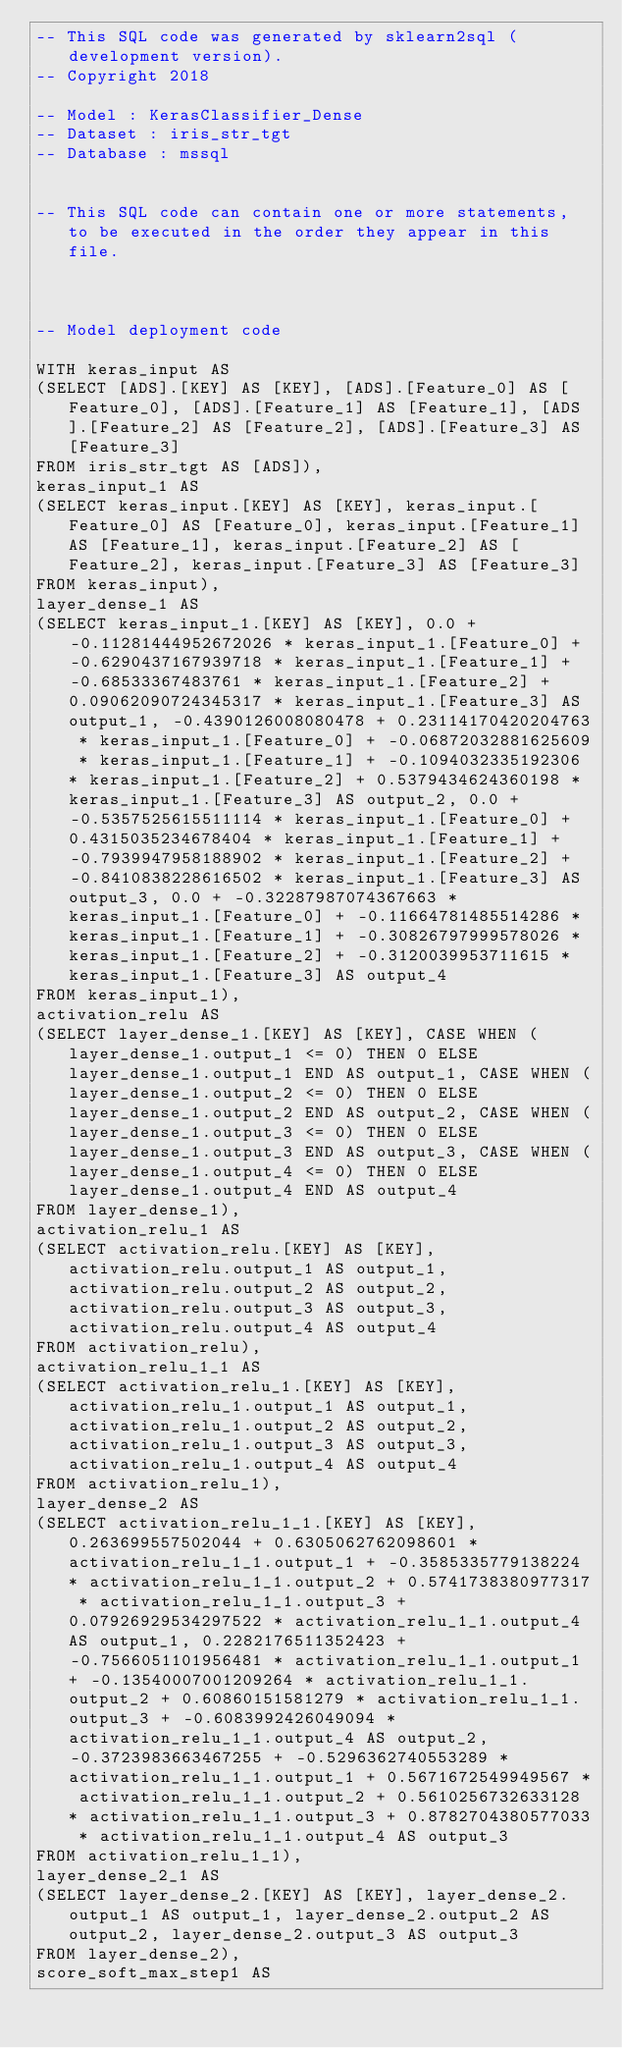<code> <loc_0><loc_0><loc_500><loc_500><_SQL_>-- This SQL code was generated by sklearn2sql (development version).
-- Copyright 2018

-- Model : KerasClassifier_Dense
-- Dataset : iris_str_tgt
-- Database : mssql


-- This SQL code can contain one or more statements, to be executed in the order they appear in this file.



-- Model deployment code

WITH keras_input AS 
(SELECT [ADS].[KEY] AS [KEY], [ADS].[Feature_0] AS [Feature_0], [ADS].[Feature_1] AS [Feature_1], [ADS].[Feature_2] AS [Feature_2], [ADS].[Feature_3] AS [Feature_3] 
FROM iris_str_tgt AS [ADS]), 
keras_input_1 AS 
(SELECT keras_input.[KEY] AS [KEY], keras_input.[Feature_0] AS [Feature_0], keras_input.[Feature_1] AS [Feature_1], keras_input.[Feature_2] AS [Feature_2], keras_input.[Feature_3] AS [Feature_3] 
FROM keras_input), 
layer_dense_1 AS 
(SELECT keras_input_1.[KEY] AS [KEY], 0.0 + -0.11281444952672026 * keras_input_1.[Feature_0] + -0.6290437167939718 * keras_input_1.[Feature_1] + -0.68533367483761 * keras_input_1.[Feature_2] + 0.09062090724345317 * keras_input_1.[Feature_3] AS output_1, -0.4390126008080478 + 0.23114170420204763 * keras_input_1.[Feature_0] + -0.06872032881625609 * keras_input_1.[Feature_1] + -0.1094032335192306 * keras_input_1.[Feature_2] + 0.5379434624360198 * keras_input_1.[Feature_3] AS output_2, 0.0 + -0.5357525615511114 * keras_input_1.[Feature_0] + 0.4315035234678404 * keras_input_1.[Feature_1] + -0.7939947958188902 * keras_input_1.[Feature_2] + -0.8410838228616502 * keras_input_1.[Feature_3] AS output_3, 0.0 + -0.32287987074367663 * keras_input_1.[Feature_0] + -0.11664781485514286 * keras_input_1.[Feature_1] + -0.30826797999578026 * keras_input_1.[Feature_2] + -0.3120039953711615 * keras_input_1.[Feature_3] AS output_4 
FROM keras_input_1), 
activation_relu AS 
(SELECT layer_dense_1.[KEY] AS [KEY], CASE WHEN (layer_dense_1.output_1 <= 0) THEN 0 ELSE layer_dense_1.output_1 END AS output_1, CASE WHEN (layer_dense_1.output_2 <= 0) THEN 0 ELSE layer_dense_1.output_2 END AS output_2, CASE WHEN (layer_dense_1.output_3 <= 0) THEN 0 ELSE layer_dense_1.output_3 END AS output_3, CASE WHEN (layer_dense_1.output_4 <= 0) THEN 0 ELSE layer_dense_1.output_4 END AS output_4 
FROM layer_dense_1), 
activation_relu_1 AS 
(SELECT activation_relu.[KEY] AS [KEY], activation_relu.output_1 AS output_1, activation_relu.output_2 AS output_2, activation_relu.output_3 AS output_3, activation_relu.output_4 AS output_4 
FROM activation_relu), 
activation_relu_1_1 AS 
(SELECT activation_relu_1.[KEY] AS [KEY], activation_relu_1.output_1 AS output_1, activation_relu_1.output_2 AS output_2, activation_relu_1.output_3 AS output_3, activation_relu_1.output_4 AS output_4 
FROM activation_relu_1), 
layer_dense_2 AS 
(SELECT activation_relu_1_1.[KEY] AS [KEY], 0.263699557502044 + 0.6305062762098601 * activation_relu_1_1.output_1 + -0.3585335779138224 * activation_relu_1_1.output_2 + 0.5741738380977317 * activation_relu_1_1.output_3 + 0.07926929534297522 * activation_relu_1_1.output_4 AS output_1, 0.2282176511352423 + -0.7566051101956481 * activation_relu_1_1.output_1 + -0.13540007001209264 * activation_relu_1_1.output_2 + 0.60860151581279 * activation_relu_1_1.output_3 + -0.6083992426049094 * activation_relu_1_1.output_4 AS output_2, -0.3723983663467255 + -0.5296362740553289 * activation_relu_1_1.output_1 + 0.5671672549949567 * activation_relu_1_1.output_2 + 0.5610256732633128 * activation_relu_1_1.output_3 + 0.8782704380577033 * activation_relu_1_1.output_4 AS output_3 
FROM activation_relu_1_1), 
layer_dense_2_1 AS 
(SELECT layer_dense_2.[KEY] AS [KEY], layer_dense_2.output_1 AS output_1, layer_dense_2.output_2 AS output_2, layer_dense_2.output_3 AS output_3 
FROM layer_dense_2), 
score_soft_max_step1 AS </code> 